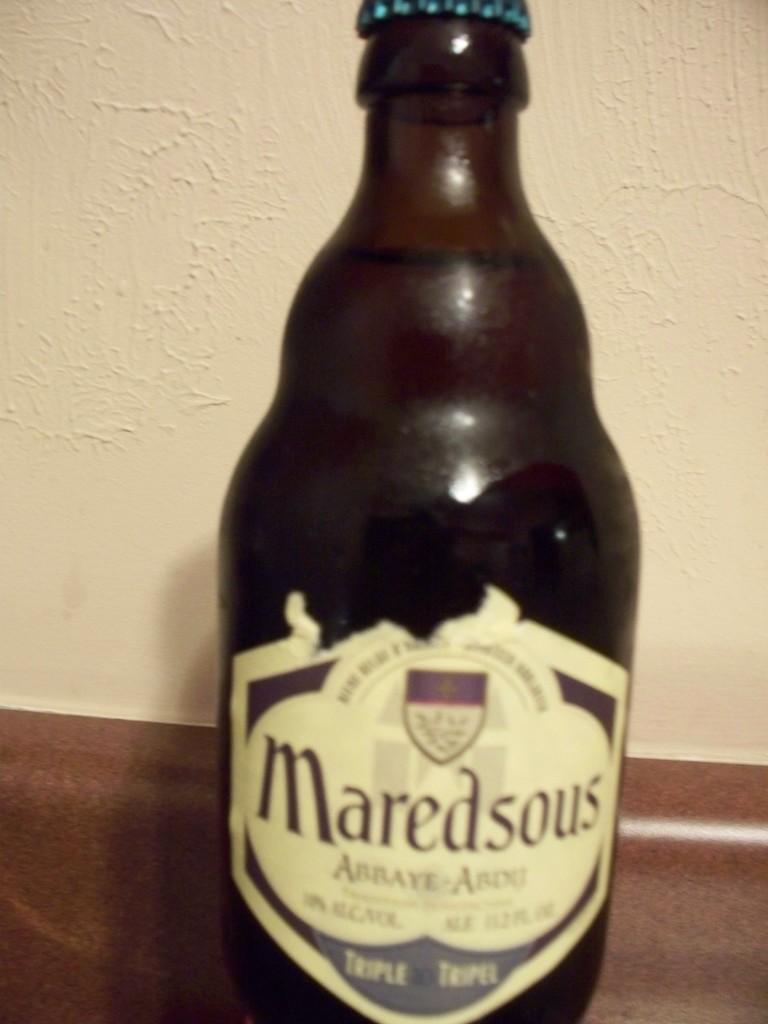What is the name of the drink?
Give a very brief answer. Maredsous. 